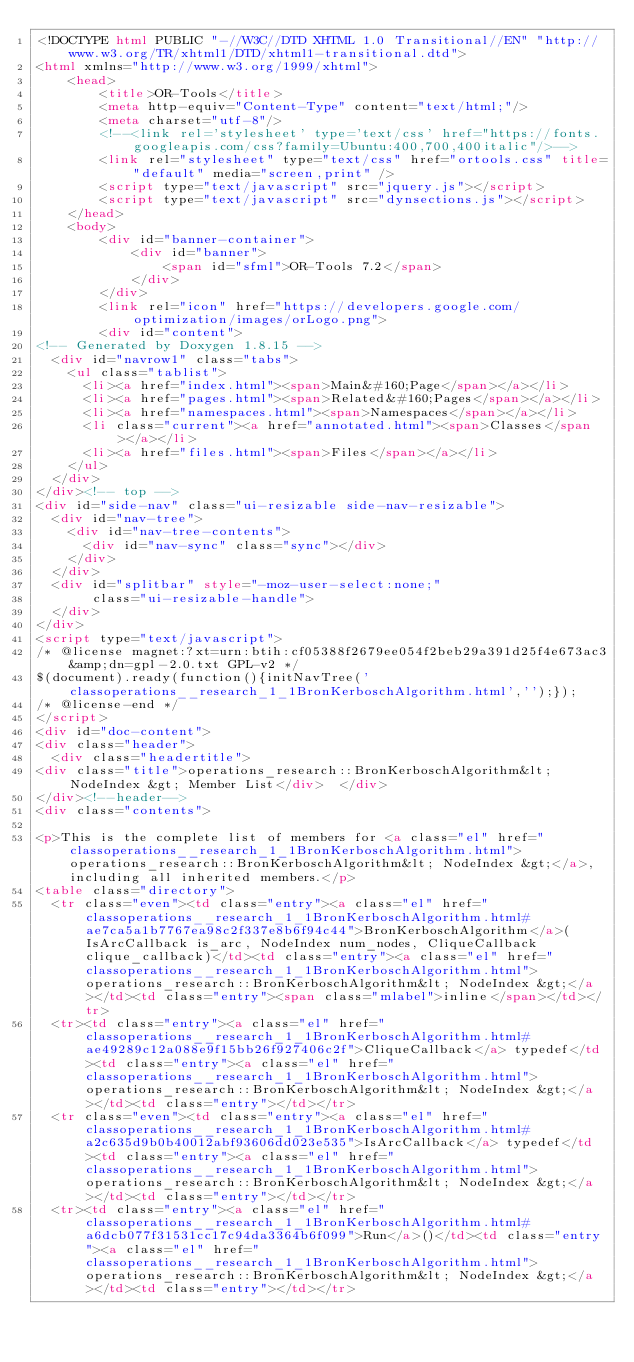<code> <loc_0><loc_0><loc_500><loc_500><_HTML_><!DOCTYPE html PUBLIC "-//W3C//DTD XHTML 1.0 Transitional//EN" "http://www.w3.org/TR/xhtml1/DTD/xhtml1-transitional.dtd">
<html xmlns="http://www.w3.org/1999/xhtml">
    <head>
        <title>OR-Tools</title>
        <meta http-equiv="Content-Type" content="text/html;"/>
        <meta charset="utf-8"/>
        <!--<link rel='stylesheet' type='text/css' href="https://fonts.googleapis.com/css?family=Ubuntu:400,700,400italic"/>-->
        <link rel="stylesheet" type="text/css" href="ortools.css" title="default" media="screen,print" />
        <script type="text/javascript" src="jquery.js"></script>
        <script type="text/javascript" src="dynsections.js"></script>
    </head>
    <body>
        <div id="banner-container">
            <div id="banner">
                <span id="sfml">OR-Tools 7.2</span>
            </div>
        </div>
        <link rel="icon" href="https://developers.google.com/optimization/images/orLogo.png">
        <div id="content">
<!-- Generated by Doxygen 1.8.15 -->
  <div id="navrow1" class="tabs">
    <ul class="tablist">
      <li><a href="index.html"><span>Main&#160;Page</span></a></li>
      <li><a href="pages.html"><span>Related&#160;Pages</span></a></li>
      <li><a href="namespaces.html"><span>Namespaces</span></a></li>
      <li class="current"><a href="annotated.html"><span>Classes</span></a></li>
      <li><a href="files.html"><span>Files</span></a></li>
    </ul>
  </div>
</div><!-- top -->
<div id="side-nav" class="ui-resizable side-nav-resizable">
  <div id="nav-tree">
    <div id="nav-tree-contents">
      <div id="nav-sync" class="sync"></div>
    </div>
  </div>
  <div id="splitbar" style="-moz-user-select:none;" 
       class="ui-resizable-handle">
  </div>
</div>
<script type="text/javascript">
/* @license magnet:?xt=urn:btih:cf05388f2679ee054f2beb29a391d25f4e673ac3&amp;dn=gpl-2.0.txt GPL-v2 */
$(document).ready(function(){initNavTree('classoperations__research_1_1BronKerboschAlgorithm.html','');});
/* @license-end */
</script>
<div id="doc-content">
<div class="header">
  <div class="headertitle">
<div class="title">operations_research::BronKerboschAlgorithm&lt; NodeIndex &gt; Member List</div>  </div>
</div><!--header-->
<div class="contents">

<p>This is the complete list of members for <a class="el" href="classoperations__research_1_1BronKerboschAlgorithm.html">operations_research::BronKerboschAlgorithm&lt; NodeIndex &gt;</a>, including all inherited members.</p>
<table class="directory">
  <tr class="even"><td class="entry"><a class="el" href="classoperations__research_1_1BronKerboschAlgorithm.html#ae7ca5a1b7767ea98c2f337e8b6f94c44">BronKerboschAlgorithm</a>(IsArcCallback is_arc, NodeIndex num_nodes, CliqueCallback clique_callback)</td><td class="entry"><a class="el" href="classoperations__research_1_1BronKerboschAlgorithm.html">operations_research::BronKerboschAlgorithm&lt; NodeIndex &gt;</a></td><td class="entry"><span class="mlabel">inline</span></td></tr>
  <tr><td class="entry"><a class="el" href="classoperations__research_1_1BronKerboschAlgorithm.html#ae49289c12a088e9f15bb26f927406c2f">CliqueCallback</a> typedef</td><td class="entry"><a class="el" href="classoperations__research_1_1BronKerboschAlgorithm.html">operations_research::BronKerboschAlgorithm&lt; NodeIndex &gt;</a></td><td class="entry"></td></tr>
  <tr class="even"><td class="entry"><a class="el" href="classoperations__research_1_1BronKerboschAlgorithm.html#a2c635d9b0b40012abf93606dd023e535">IsArcCallback</a> typedef</td><td class="entry"><a class="el" href="classoperations__research_1_1BronKerboschAlgorithm.html">operations_research::BronKerboschAlgorithm&lt; NodeIndex &gt;</a></td><td class="entry"></td></tr>
  <tr><td class="entry"><a class="el" href="classoperations__research_1_1BronKerboschAlgorithm.html#a6dcb077f31531cc17c94da3364b6f099">Run</a>()</td><td class="entry"><a class="el" href="classoperations__research_1_1BronKerboschAlgorithm.html">operations_research::BronKerboschAlgorithm&lt; NodeIndex &gt;</a></td><td class="entry"></td></tr></code> 